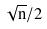<formula> <loc_0><loc_0><loc_500><loc_500>\sqrt { n } / 2</formula> 